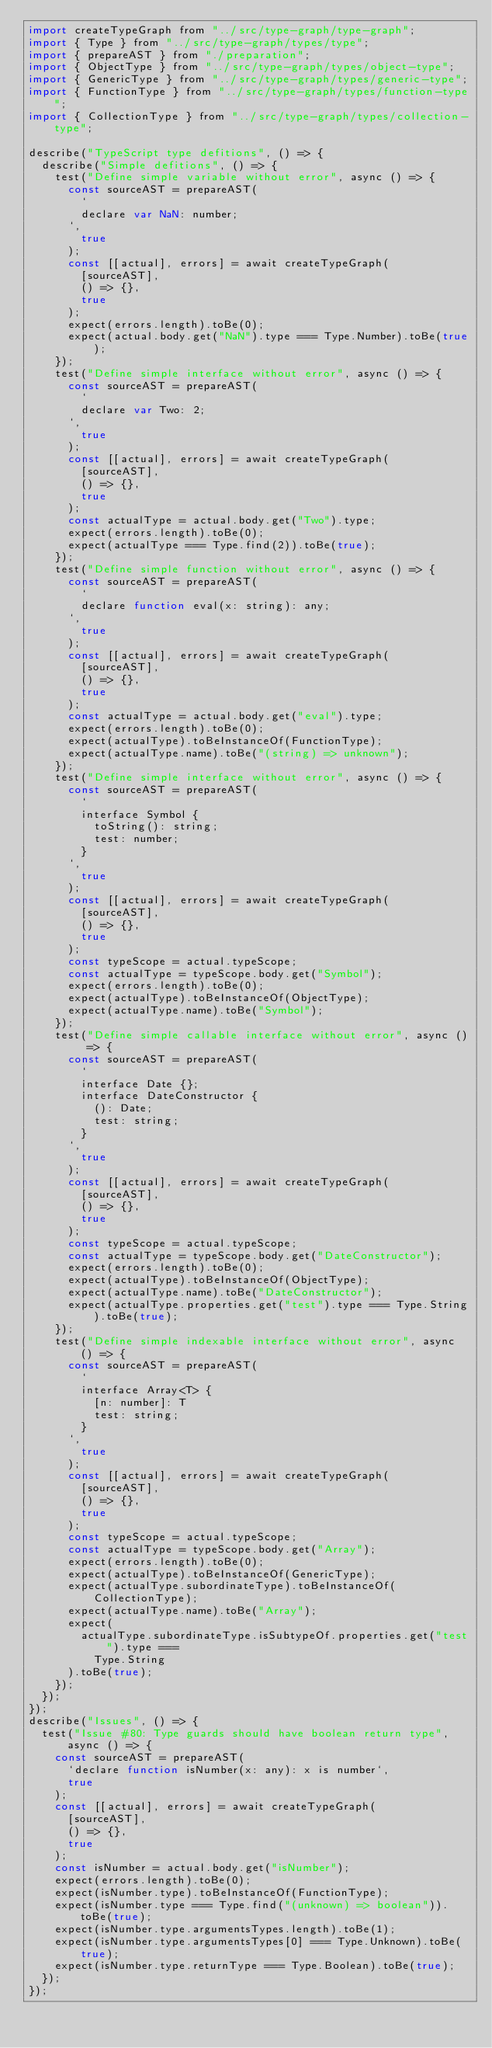Convert code to text. <code><loc_0><loc_0><loc_500><loc_500><_JavaScript_>import createTypeGraph from "../src/type-graph/type-graph";
import { Type } from "../src/type-graph/types/type";
import { prepareAST } from "./preparation";
import { ObjectType } from "../src/type-graph/types/object-type";
import { GenericType } from "../src/type-graph/types/generic-type";
import { FunctionType } from "../src/type-graph/types/function-type";
import { CollectionType } from "../src/type-graph/types/collection-type";

describe("TypeScript type defitions", () => {
  describe("Simple defitions", () => {
    test("Define simple variable without error", async () => {
      const sourceAST = prepareAST(
        `
        declare var NaN: number; 
      `,
        true
      );
      const [[actual], errors] = await createTypeGraph(
        [sourceAST],
        () => {},
        true
      );
      expect(errors.length).toBe(0);
      expect(actual.body.get("NaN").type === Type.Number).toBe(true);
    });
    test("Define simple interface without error", async () => {
      const sourceAST = prepareAST(
        `
        declare var Two: 2; 
      `,
        true
      );
      const [[actual], errors] = await createTypeGraph(
        [sourceAST],
        () => {},
        true
      );
      const actualType = actual.body.get("Two").type;
      expect(errors.length).toBe(0);
      expect(actualType === Type.find(2)).toBe(true);
    });
    test("Define simple function without error", async () => {
      const sourceAST = prepareAST(
        `
        declare function eval(x: string): any;
      `,
        true
      );
      const [[actual], errors] = await createTypeGraph(
        [sourceAST],
        () => {},
        true
      );
      const actualType = actual.body.get("eval").type;
      expect(errors.length).toBe(0);
      expect(actualType).toBeInstanceOf(FunctionType);
      expect(actualType.name).toBe("(string) => unknown");
    });
    test("Define simple interface without error", async () => {
      const sourceAST = prepareAST(
        `
        interface Symbol {
          toString(): string;
          test: number;
        }
      `,
        true
      );
      const [[actual], errors] = await createTypeGraph(
        [sourceAST],
        () => {},
        true
      );
      const typeScope = actual.typeScope;
      const actualType = typeScope.body.get("Symbol");
      expect(errors.length).toBe(0);
      expect(actualType).toBeInstanceOf(ObjectType);
      expect(actualType.name).toBe("Symbol");
    });
    test("Define simple callable interface without error", async () => {
      const sourceAST = prepareAST(
        `
        interface Date {};
        interface DateConstructor {
          (): Date;
          test: string;
        }
      `,
        true
      );
      const [[actual], errors] = await createTypeGraph(
        [sourceAST],
        () => {},
        true
      );
      const typeScope = actual.typeScope;
      const actualType = typeScope.body.get("DateConstructor");
      expect(errors.length).toBe(0);
      expect(actualType).toBeInstanceOf(ObjectType);
      expect(actualType.name).toBe("DateConstructor");
      expect(actualType.properties.get("test").type === Type.String).toBe(true);
    });
    test("Define simple indexable interface without error", async () => {
      const sourceAST = prepareAST(
        `
        interface Array<T> {
          [n: number]: T
          test: string;
        }
      `,
        true
      );
      const [[actual], errors] = await createTypeGraph(
        [sourceAST],
        () => {},
        true
      );
      const typeScope = actual.typeScope;
      const actualType = typeScope.body.get("Array");
      expect(errors.length).toBe(0);
      expect(actualType).toBeInstanceOf(GenericType);
      expect(actualType.subordinateType).toBeInstanceOf(CollectionType);
      expect(actualType.name).toBe("Array");
      expect(
        actualType.subordinateType.isSubtypeOf.properties.get("test").type ===
          Type.String
      ).toBe(true);
    });
  });
});
describe("Issues", () => {
  test("Issue #80: Type guards should have boolean return type", async () => {
    const sourceAST = prepareAST(
      `declare function isNumber(x: any): x is number`,
      true
    );
    const [[actual], errors] = await createTypeGraph(
      [sourceAST],
      () => {},
      true
    );
    const isNumber = actual.body.get("isNumber");
    expect(errors.length).toBe(0);
    expect(isNumber.type).toBeInstanceOf(FunctionType);
    expect(isNumber.type === Type.find("(unknown) => boolean")).toBe(true);
    expect(isNumber.type.argumentsTypes.length).toBe(1);
    expect(isNumber.type.argumentsTypes[0] === Type.Unknown).toBe(true);
    expect(isNumber.type.returnType === Type.Boolean).toBe(true);
  });
});
</code> 